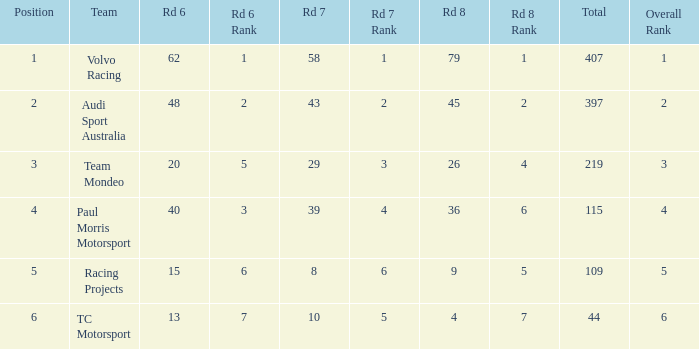What is the sum of values of Rd 7 with RD 6 less than 48 and Rd 8 less than 4 for TC Motorsport in a position greater than 1? None. 